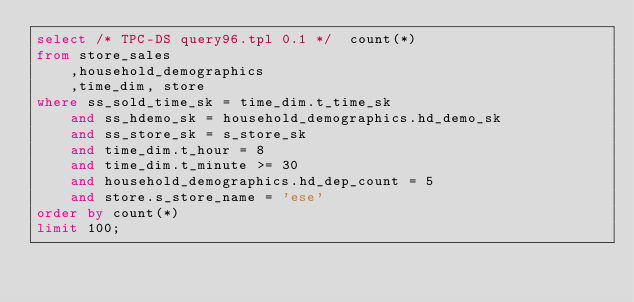<code> <loc_0><loc_0><loc_500><loc_500><_SQL_>select /* TPC-DS query96.tpl 0.1 */  count(*) 
from store_sales
    ,household_demographics 
    ,time_dim, store
where ss_sold_time_sk = time_dim.t_time_sk   
    and ss_hdemo_sk = household_demographics.hd_demo_sk 
    and ss_store_sk = s_store_sk
    and time_dim.t_hour = 8
    and time_dim.t_minute >= 30
    and household_demographics.hd_dep_count = 5
    and store.s_store_name = 'ese'
order by count(*)
limit 100;</code> 